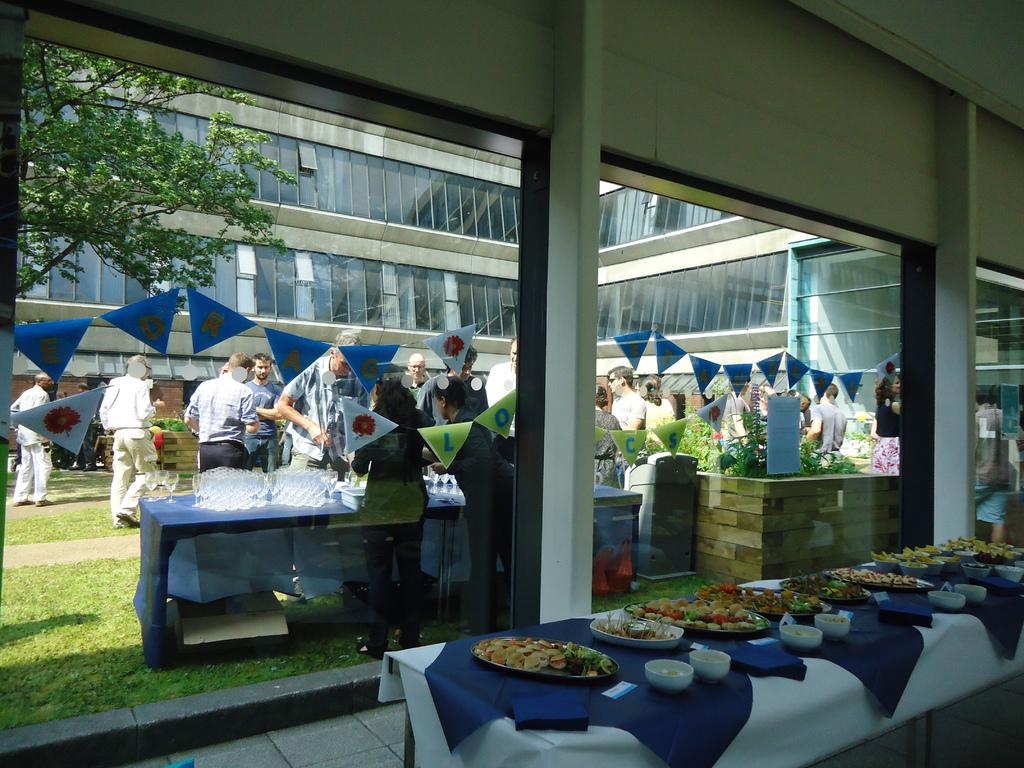What type of structure is visible in the image? There is a building in the image. What natural element is present in the image? There is a tree in the image. Where are the flags located in the image? The flags are hanging on a wall in the image. What are the people in the image doing? There are people walking in the image. What type of ground surface is visible in the image? There is grass in the image. What can be seen on the table in the image? There is a table with food served on plates in the image. What type of robin can be seen sitting on the steel part of the building in the image? There is no robin or steel part of the building present in the image. 